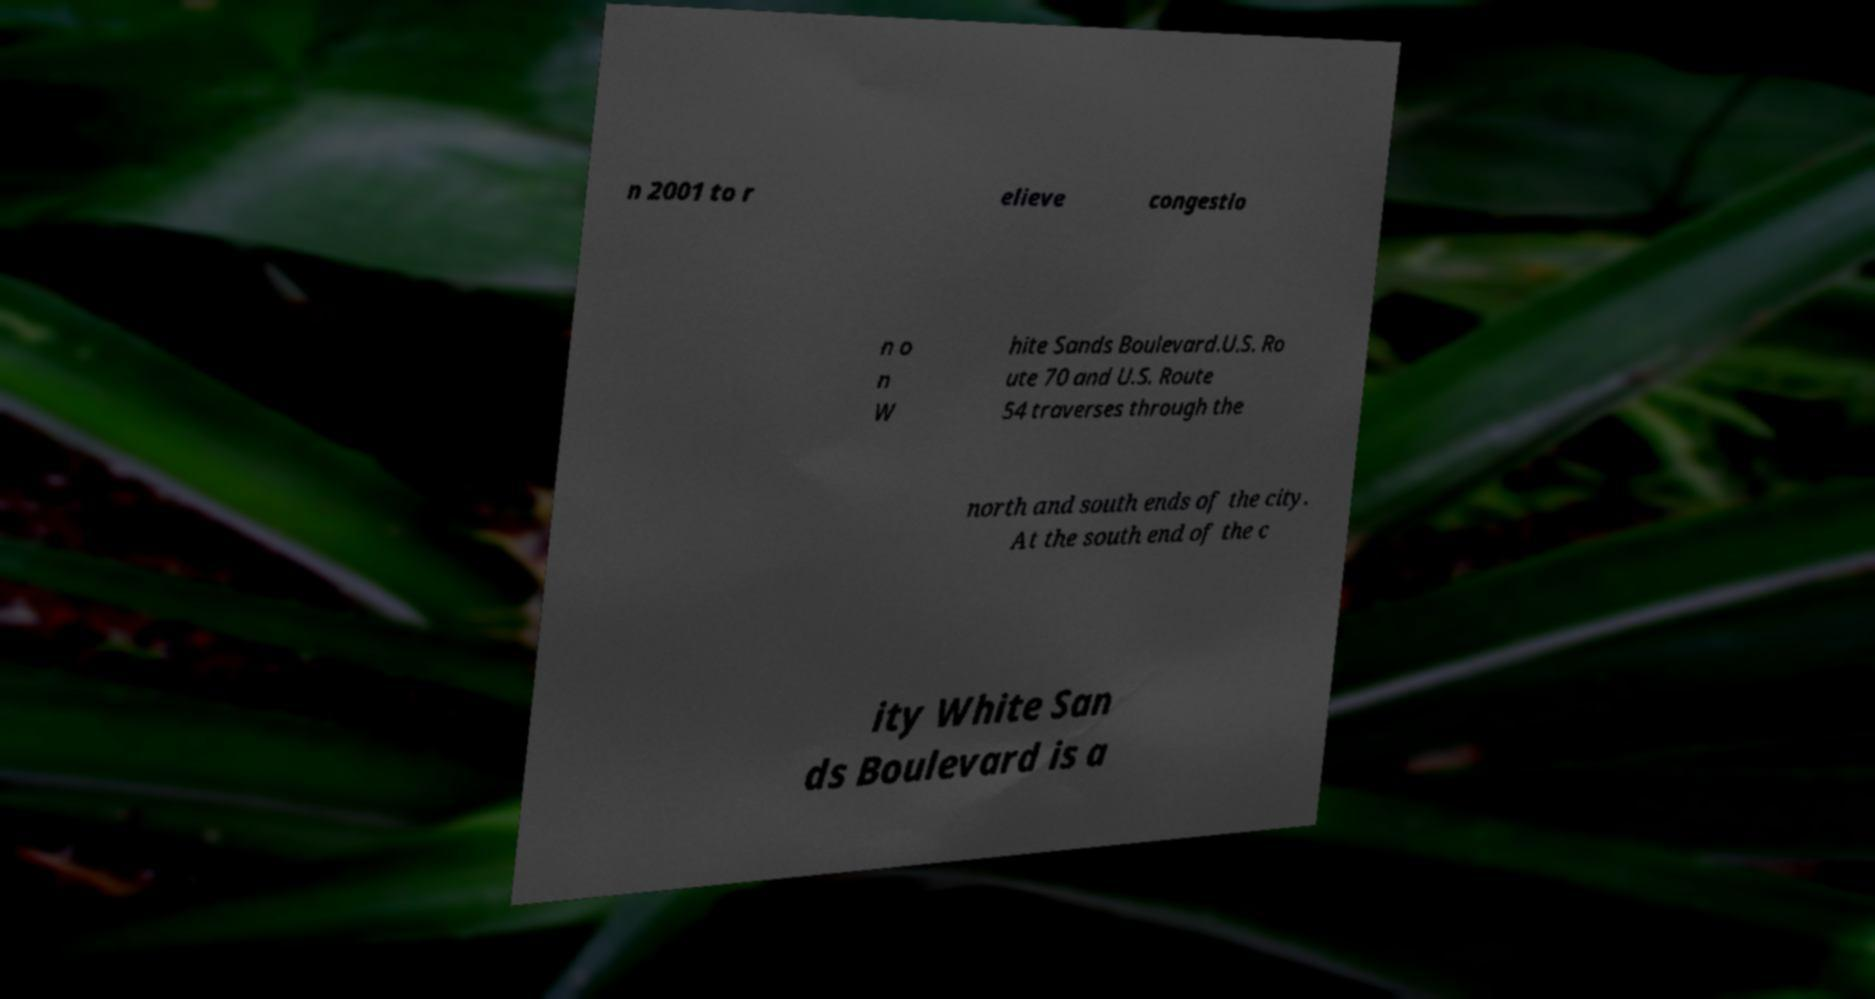Please identify and transcribe the text found in this image. n 2001 to r elieve congestio n o n W hite Sands Boulevard.U.S. Ro ute 70 and U.S. Route 54 traverses through the north and south ends of the city. At the south end of the c ity White San ds Boulevard is a 